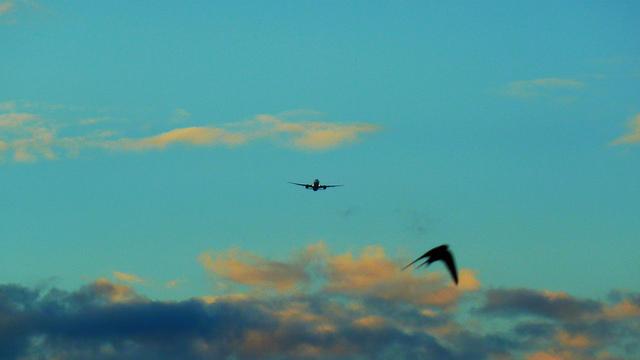How many birds?
Give a very brief answer. 1. Is the sky mostly clear?
Write a very short answer. Yes. What are the objects in the sky?
Give a very brief answer. Birds. How long is the bird's beaks?
Write a very short answer. 3 inches. How's the weather?
Give a very brief answer. Sunny. What color is the sky?
Quick response, please. Blue. What is flying in the sky?
Write a very short answer. Plane. What is flying in the air?
Write a very short answer. Plane. What is in the sky?
Concise answer only. Plane. What type of birds are these?
Quick response, please. Eagle. Was this taken at night?
Give a very brief answer. No. What are the objects flying in the sky?
Answer briefly. Plane and bird. Are there a lot of kites in the sky?
Keep it brief. No. Are there a lot of kites?
Quick response, please. No. How many planes?
Answer briefly. 1. What are the many objects in the air?
Concise answer only. 2. 